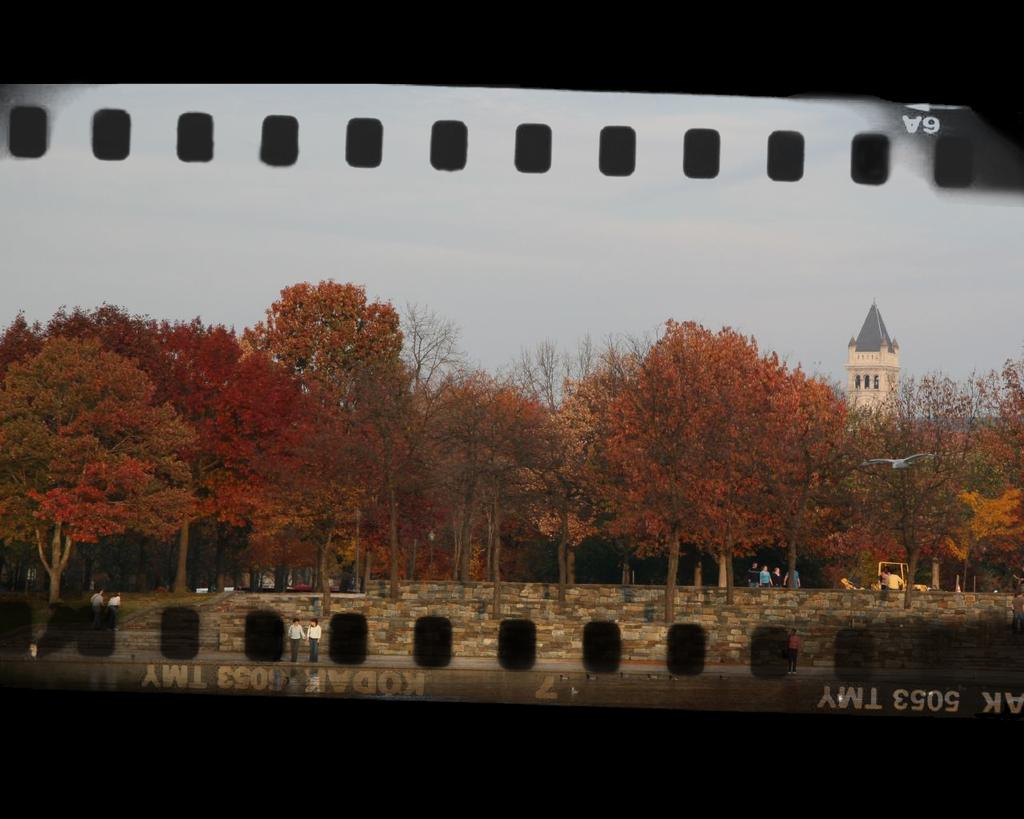<image>
Provide a brief description of the given image. A film negative has Kodak on the edge of the film. 